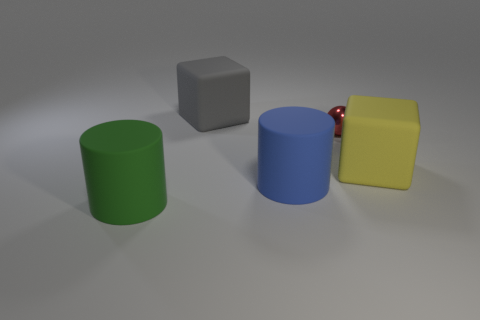Is there any other thing that has the same shape as the tiny red thing?
Your response must be concise. No. How many objects are to the right of the red metallic object?
Your answer should be compact. 1. What is the color of the other cylinder that is made of the same material as the big blue cylinder?
Make the answer very short. Green. Is the size of the gray matte block the same as the rubber cylinder left of the blue cylinder?
Keep it short and to the point. Yes. What size is the metal ball that is to the right of the big cylinder that is to the left of the cylinder on the right side of the big green object?
Your answer should be very brief. Small. How many matte objects are brown spheres or gray blocks?
Make the answer very short. 1. There is a cube to the left of the large blue thing; what color is it?
Make the answer very short. Gray. What shape is the yellow thing that is the same size as the green object?
Provide a short and direct response. Cube. What number of objects are large cylinders on the left side of the gray matte cube or large things that are behind the green cylinder?
Provide a succinct answer. 4. What is the material of the yellow object that is the same size as the blue rubber cylinder?
Your answer should be very brief. Rubber. 